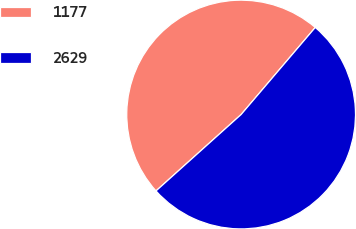<chart> <loc_0><loc_0><loc_500><loc_500><pie_chart><fcel>1177<fcel>2629<nl><fcel>47.87%<fcel>52.13%<nl></chart> 